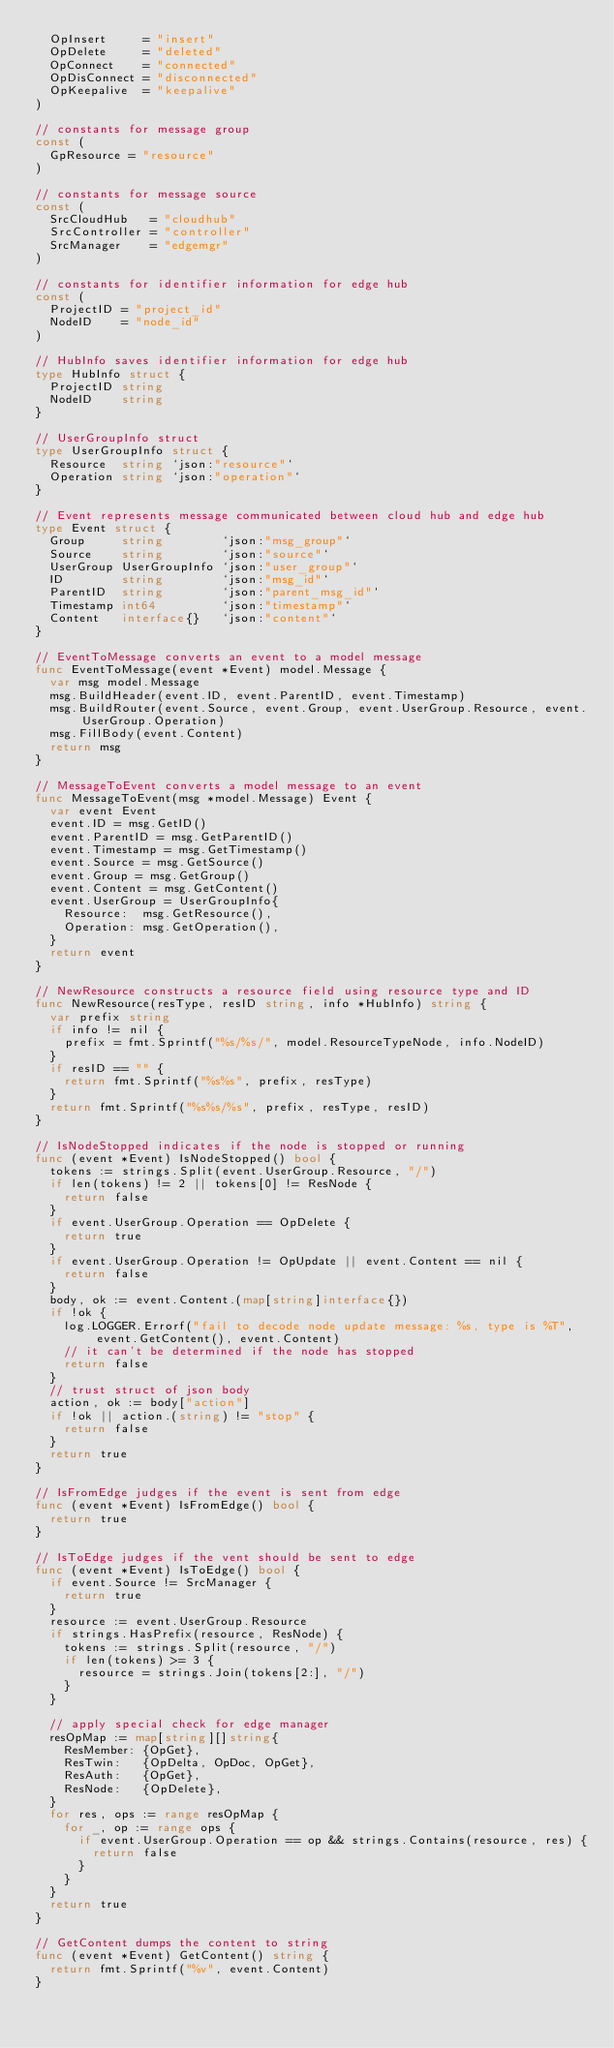<code> <loc_0><loc_0><loc_500><loc_500><_Go_>	OpInsert     = "insert"
	OpDelete     = "deleted"
	OpConnect    = "connected"
	OpDisConnect = "disconnected"
	OpKeepalive  = "keepalive"
)

// constants for message group
const (
	GpResource = "resource"
)

// constants for message source
const (
	SrcCloudHub   = "cloudhub"
	SrcController = "controller"
	SrcManager    = "edgemgr"
)

// constants for identifier information for edge hub
const (
	ProjectID = "project_id"
	NodeID    = "node_id"
)

// HubInfo saves identifier information for edge hub
type HubInfo struct {
	ProjectID string
	NodeID    string
}

// UserGroupInfo struct
type UserGroupInfo struct {
	Resource  string `json:"resource"`
	Operation string `json:"operation"`
}

// Event represents message communicated between cloud hub and edge hub
type Event struct {
	Group     string        `json:"msg_group"`
	Source    string        `json:"source"`
	UserGroup UserGroupInfo `json:"user_group"`
	ID        string        `json:"msg_id"`
	ParentID  string        `json:"parent_msg_id"`
	Timestamp int64         `json:"timestamp"`
	Content   interface{}   `json:"content"`
}

// EventToMessage converts an event to a model message
func EventToMessage(event *Event) model.Message {
	var msg model.Message
	msg.BuildHeader(event.ID, event.ParentID, event.Timestamp)
	msg.BuildRouter(event.Source, event.Group, event.UserGroup.Resource, event.UserGroup.Operation)
	msg.FillBody(event.Content)
	return msg
}

// MessageToEvent converts a model message to an event
func MessageToEvent(msg *model.Message) Event {
	var event Event
	event.ID = msg.GetID()
	event.ParentID = msg.GetParentID()
	event.Timestamp = msg.GetTimestamp()
	event.Source = msg.GetSource()
	event.Group = msg.GetGroup()
	event.Content = msg.GetContent()
	event.UserGroup = UserGroupInfo{
		Resource:  msg.GetResource(),
		Operation: msg.GetOperation(),
	}
	return event
}

// NewResource constructs a resource field using resource type and ID
func NewResource(resType, resID string, info *HubInfo) string {
	var prefix string
	if info != nil {
		prefix = fmt.Sprintf("%s/%s/", model.ResourceTypeNode, info.NodeID)
	}
	if resID == "" {
		return fmt.Sprintf("%s%s", prefix, resType)
	}
	return fmt.Sprintf("%s%s/%s", prefix, resType, resID)
}

// IsNodeStopped indicates if the node is stopped or running
func (event *Event) IsNodeStopped() bool {
	tokens := strings.Split(event.UserGroup.Resource, "/")
	if len(tokens) != 2 || tokens[0] != ResNode {
		return false
	}
	if event.UserGroup.Operation == OpDelete {
		return true
	}
	if event.UserGroup.Operation != OpUpdate || event.Content == nil {
		return false
	}
	body, ok := event.Content.(map[string]interface{})
	if !ok {
		log.LOGGER.Errorf("fail to decode node update message: %s, type is %T", event.GetContent(), event.Content)
		// it can't be determined if the node has stopped
		return false
	}
	// trust struct of json body
	action, ok := body["action"]
	if !ok || action.(string) != "stop" {
		return false
	}
	return true
}

// IsFromEdge judges if the event is sent from edge
func (event *Event) IsFromEdge() bool {
	return true
}

// IsToEdge judges if the vent should be sent to edge
func (event *Event) IsToEdge() bool {
	if event.Source != SrcManager {
		return true
	}
	resource := event.UserGroup.Resource
	if strings.HasPrefix(resource, ResNode) {
		tokens := strings.Split(resource, "/")
		if len(tokens) >= 3 {
			resource = strings.Join(tokens[2:], "/")
		}
	}

	// apply special check for edge manager
	resOpMap := map[string][]string{
		ResMember: {OpGet},
		ResTwin:   {OpDelta, OpDoc, OpGet},
		ResAuth:   {OpGet},
		ResNode:   {OpDelete},
	}
	for res, ops := range resOpMap {
		for _, op := range ops {
			if event.UserGroup.Operation == op && strings.Contains(resource, res) {
				return false
			}
		}
	}
	return true
}

// GetContent dumps the content to string
func (event *Event) GetContent() string {
	return fmt.Sprintf("%v", event.Content)
}
</code> 